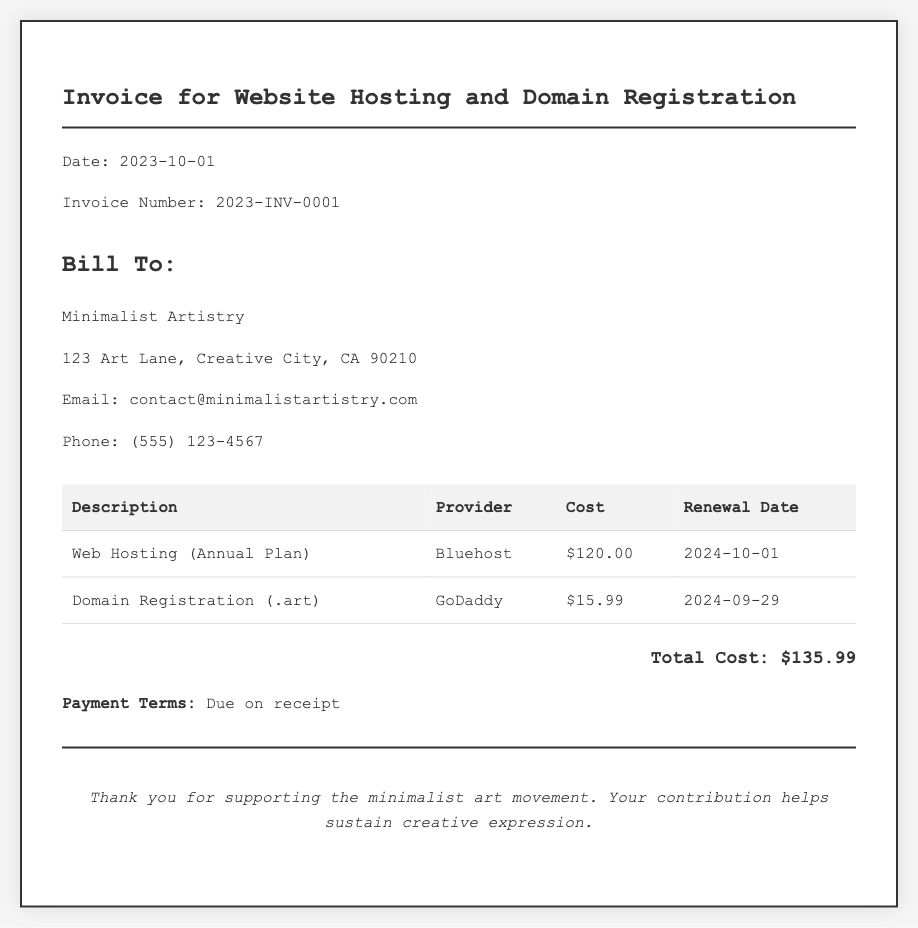What is the date of the invoice? The date of the invoice is provided in the document under the header section, specified as "2023-10-01".
Answer: 2023-10-01 What is the total cost listed in the invoice? The total cost is mentioned in the details section and is highlighted as a total amount, which is $135.99.
Answer: $135.99 Who is the provider for the web hosting service? The provider for the web hosting service is specified in the details section where "Bluehost" is mentioned.
Answer: Bluehost What is the renewal date for the domain registration? The renewal date is given in the details table for the domain registration, which is "2024-09-29".
Answer: 2024-09-29 What is the cost of the domain registration? The cost for domain registration is provided in the details table, which states "$15.99".
Answer: $15.99 What is the invoice number? The invoice number is indicated at the top of the document as "2023-INV-0001".
Answer: 2023-INV-0001 When is the renewal date for the web hosting service? The renewal date for the web hosting service is mentioned in the details table, specifically as "2024-10-01".
Answer: 2024-10-01 What payment terms are specified? The document includes payment terms that state payment is "Due on receipt".
Answer: Due on receipt Who is the bill recipient? The recipient of the bill is specified in the bill to section as "Minimalist Artistry".
Answer: Minimalist Artistry 